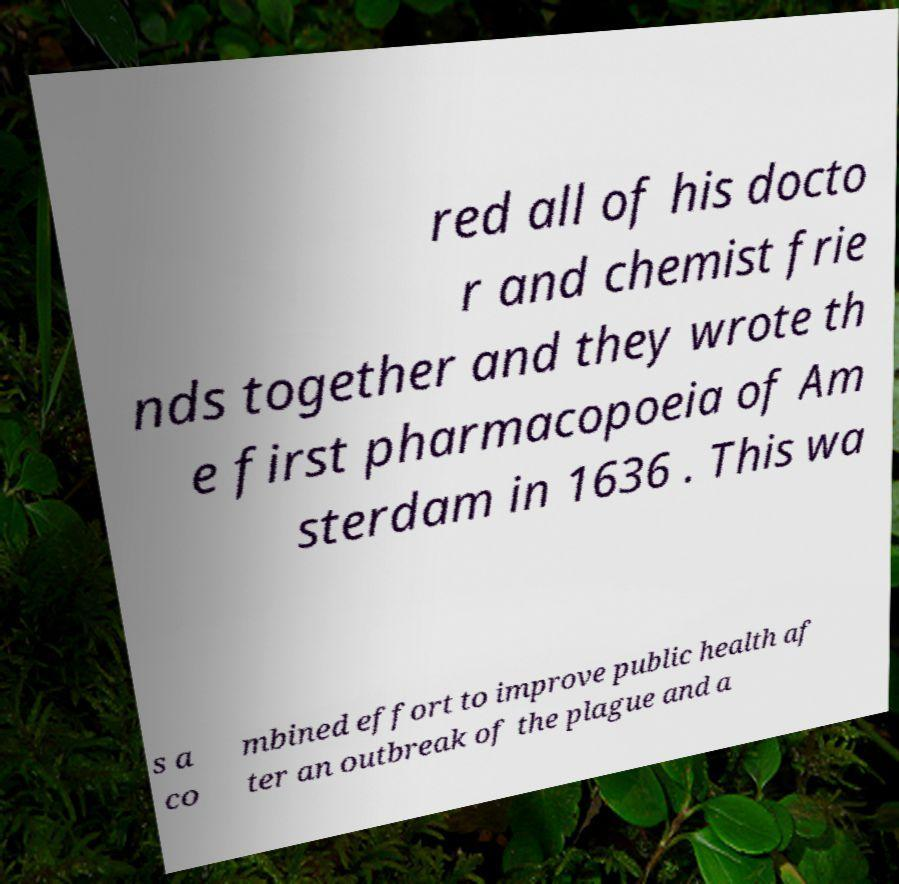For documentation purposes, I need the text within this image transcribed. Could you provide that? red all of his docto r and chemist frie nds together and they wrote th e first pharmacopoeia of Am sterdam in 1636 . This wa s a co mbined effort to improve public health af ter an outbreak of the plague and a 